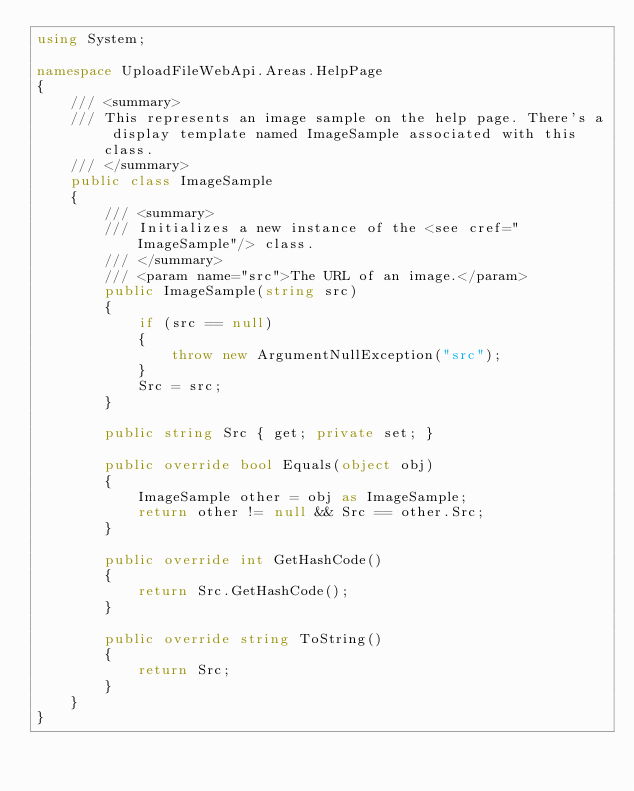<code> <loc_0><loc_0><loc_500><loc_500><_C#_>using System;

namespace UploadFileWebApi.Areas.HelpPage
{
    /// <summary>
    /// This represents an image sample on the help page. There's a display template named ImageSample associated with this class.
    /// </summary>
    public class ImageSample
    {
        /// <summary>
        /// Initializes a new instance of the <see cref="ImageSample"/> class.
        /// </summary>
        /// <param name="src">The URL of an image.</param>
        public ImageSample(string src)
        {
            if (src == null)
            {
                throw new ArgumentNullException("src");
            }
            Src = src;
        }

        public string Src { get; private set; }

        public override bool Equals(object obj)
        {
            ImageSample other = obj as ImageSample;
            return other != null && Src == other.Src;
        }

        public override int GetHashCode()
        {
            return Src.GetHashCode();
        }

        public override string ToString()
        {
            return Src;
        }
    }
}</code> 